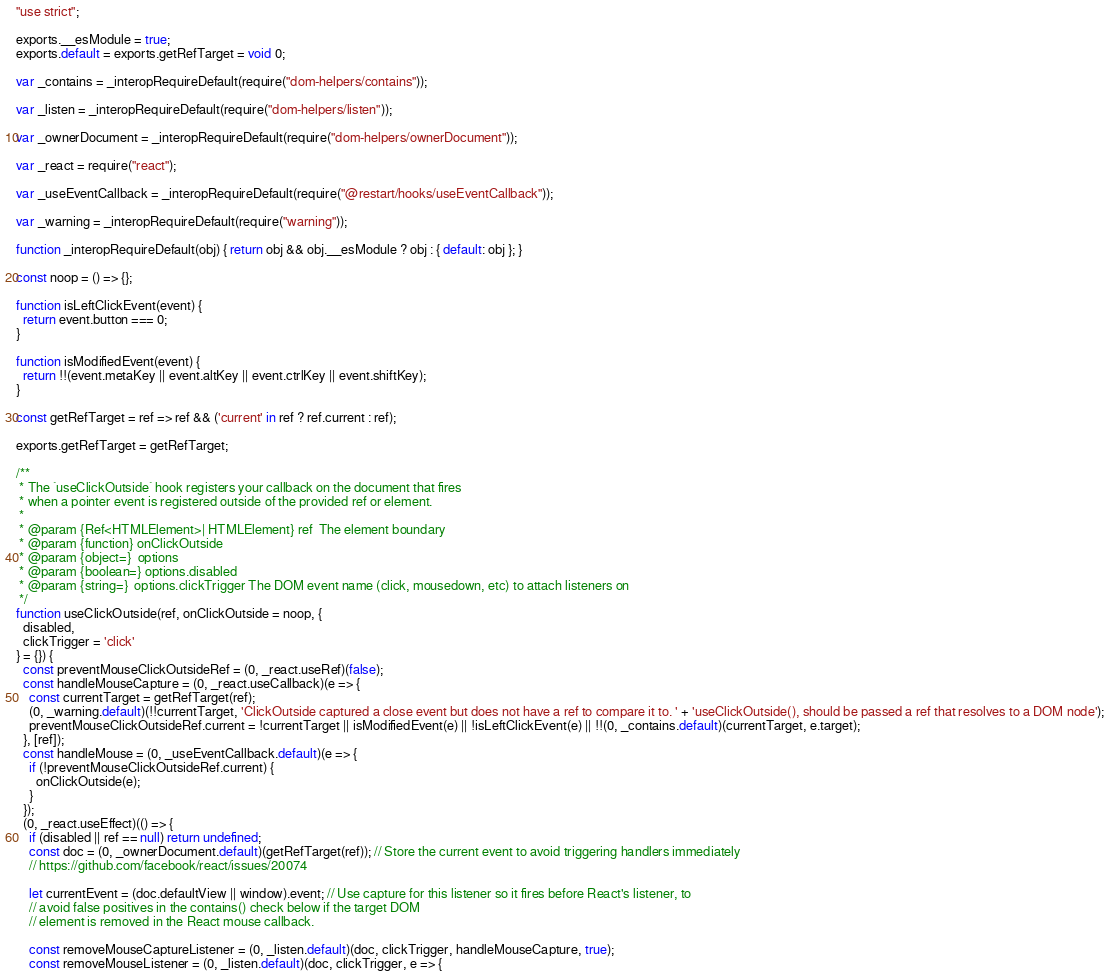<code> <loc_0><loc_0><loc_500><loc_500><_JavaScript_>"use strict";

exports.__esModule = true;
exports.default = exports.getRefTarget = void 0;

var _contains = _interopRequireDefault(require("dom-helpers/contains"));

var _listen = _interopRequireDefault(require("dom-helpers/listen"));

var _ownerDocument = _interopRequireDefault(require("dom-helpers/ownerDocument"));

var _react = require("react");

var _useEventCallback = _interopRequireDefault(require("@restart/hooks/useEventCallback"));

var _warning = _interopRequireDefault(require("warning"));

function _interopRequireDefault(obj) { return obj && obj.__esModule ? obj : { default: obj }; }

const noop = () => {};

function isLeftClickEvent(event) {
  return event.button === 0;
}

function isModifiedEvent(event) {
  return !!(event.metaKey || event.altKey || event.ctrlKey || event.shiftKey);
}

const getRefTarget = ref => ref && ('current' in ref ? ref.current : ref);

exports.getRefTarget = getRefTarget;

/**
 * The `useClickOutside` hook registers your callback on the document that fires
 * when a pointer event is registered outside of the provided ref or element.
 *
 * @param {Ref<HTMLElement>| HTMLElement} ref  The element boundary
 * @param {function} onClickOutside
 * @param {object=}  options
 * @param {boolean=} options.disabled
 * @param {string=}  options.clickTrigger The DOM event name (click, mousedown, etc) to attach listeners on
 */
function useClickOutside(ref, onClickOutside = noop, {
  disabled,
  clickTrigger = 'click'
} = {}) {
  const preventMouseClickOutsideRef = (0, _react.useRef)(false);
  const handleMouseCapture = (0, _react.useCallback)(e => {
    const currentTarget = getRefTarget(ref);
    (0, _warning.default)(!!currentTarget, 'ClickOutside captured a close event but does not have a ref to compare it to. ' + 'useClickOutside(), should be passed a ref that resolves to a DOM node');
    preventMouseClickOutsideRef.current = !currentTarget || isModifiedEvent(e) || !isLeftClickEvent(e) || !!(0, _contains.default)(currentTarget, e.target);
  }, [ref]);
  const handleMouse = (0, _useEventCallback.default)(e => {
    if (!preventMouseClickOutsideRef.current) {
      onClickOutside(e);
    }
  });
  (0, _react.useEffect)(() => {
    if (disabled || ref == null) return undefined;
    const doc = (0, _ownerDocument.default)(getRefTarget(ref)); // Store the current event to avoid triggering handlers immediately
    // https://github.com/facebook/react/issues/20074

    let currentEvent = (doc.defaultView || window).event; // Use capture for this listener so it fires before React's listener, to
    // avoid false positives in the contains() check below if the target DOM
    // element is removed in the React mouse callback.

    const removeMouseCaptureListener = (0, _listen.default)(doc, clickTrigger, handleMouseCapture, true);
    const removeMouseListener = (0, _listen.default)(doc, clickTrigger, e => {</code> 